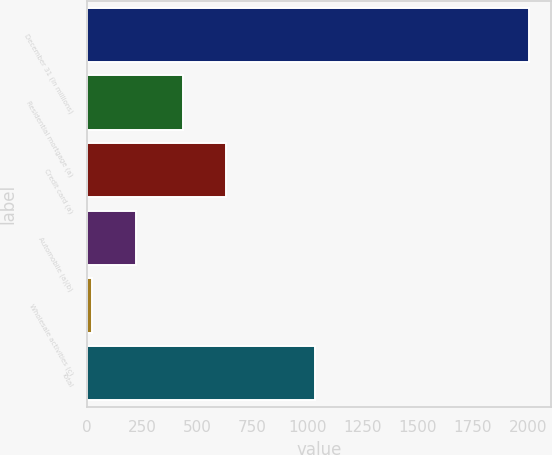<chart> <loc_0><loc_0><loc_500><loc_500><bar_chart><fcel>December 31 (in millions)<fcel>Residential mortgage (a)<fcel>Credit card (a)<fcel>Automobile (a)(b)<fcel>Wholesale activities (c)<fcel>Total<nl><fcel>2004<fcel>433<fcel>631.1<fcel>221.1<fcel>23<fcel>1035<nl></chart> 